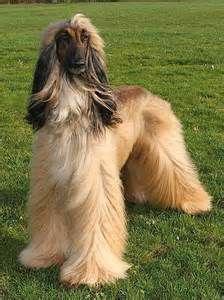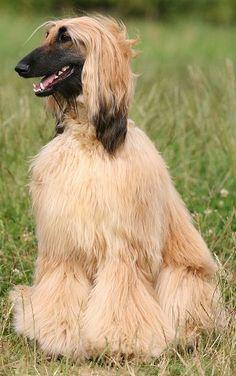The first image is the image on the left, the second image is the image on the right. Given the left and right images, does the statement "The dog in the image on the right is turned toward the right." hold true? Answer yes or no. No. 